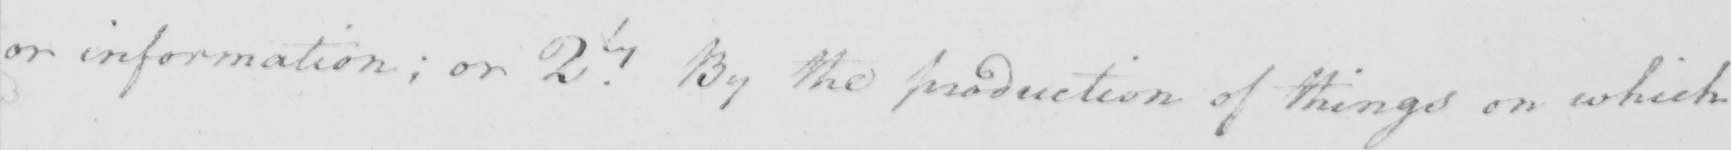Please transcribe the handwritten text in this image. or information ; or 2.ly By the production of things on which 